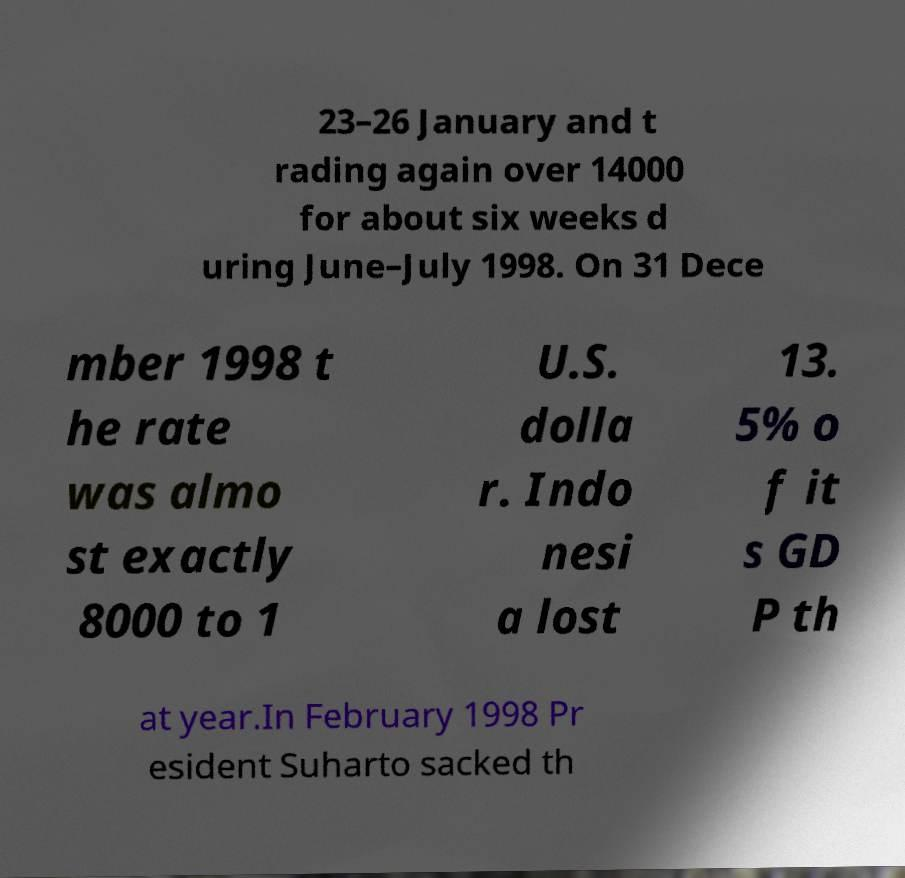What messages or text are displayed in this image? I need them in a readable, typed format. 23–26 January and t rading again over 14000 for about six weeks d uring June–July 1998. On 31 Dece mber 1998 t he rate was almo st exactly 8000 to 1 U.S. dolla r. Indo nesi a lost 13. 5% o f it s GD P th at year.In February 1998 Pr esident Suharto sacked th 